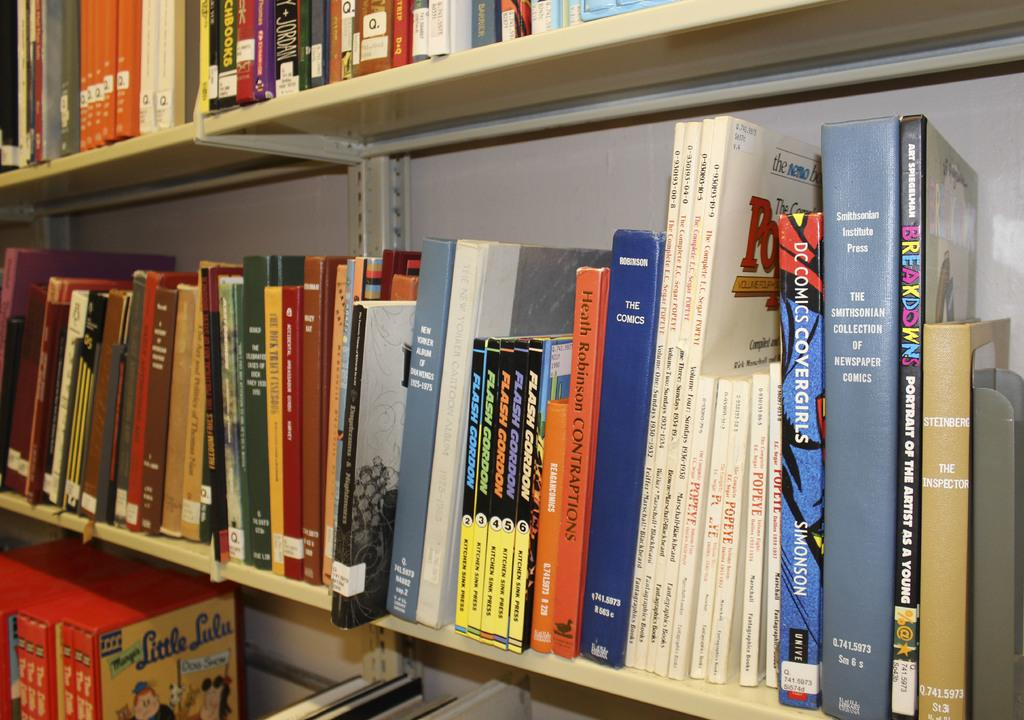What type of objects can be seen in the shelves in the image? There are books in the shelves in the image. How many shelves are visible in the image? The number of shelves is not specified in the provided facts, so it cannot be determined from the image. What might be the purpose of the books in the shelves? The books in the shelves might be for reading, reference, or decoration. What type of chicken can be seen in the image? There is no chicken present in the image; it features books in shelves. 